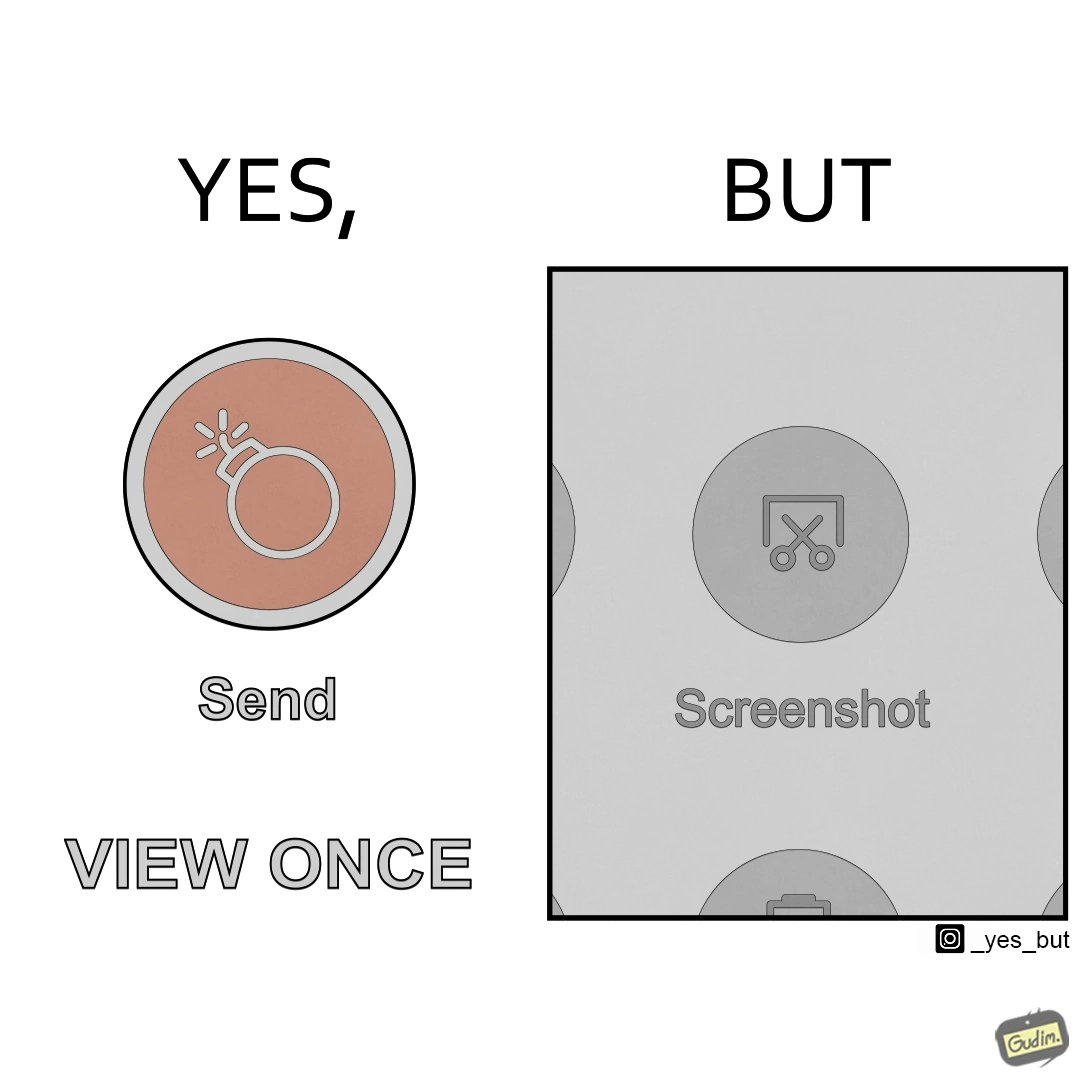Is this a satirical image? Yes, this image is satirical. 